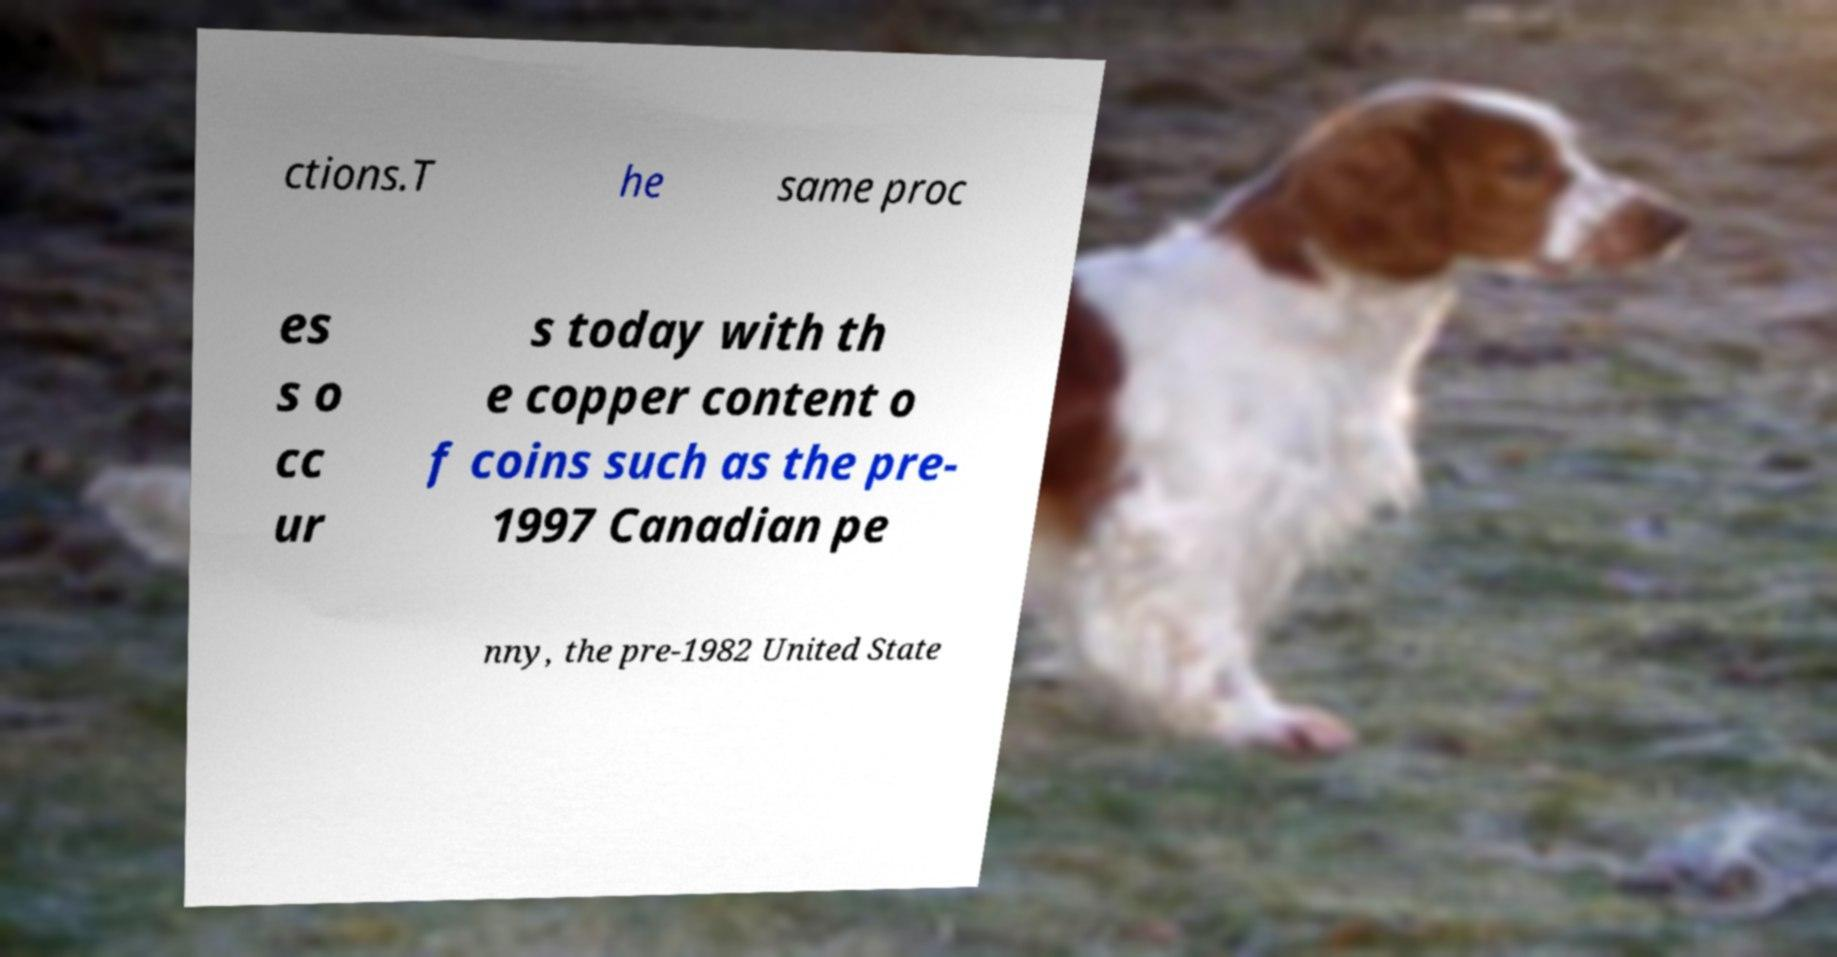Can you read and provide the text displayed in the image?This photo seems to have some interesting text. Can you extract and type it out for me? ctions.T he same proc es s o cc ur s today with th e copper content o f coins such as the pre- 1997 Canadian pe nny, the pre-1982 United State 